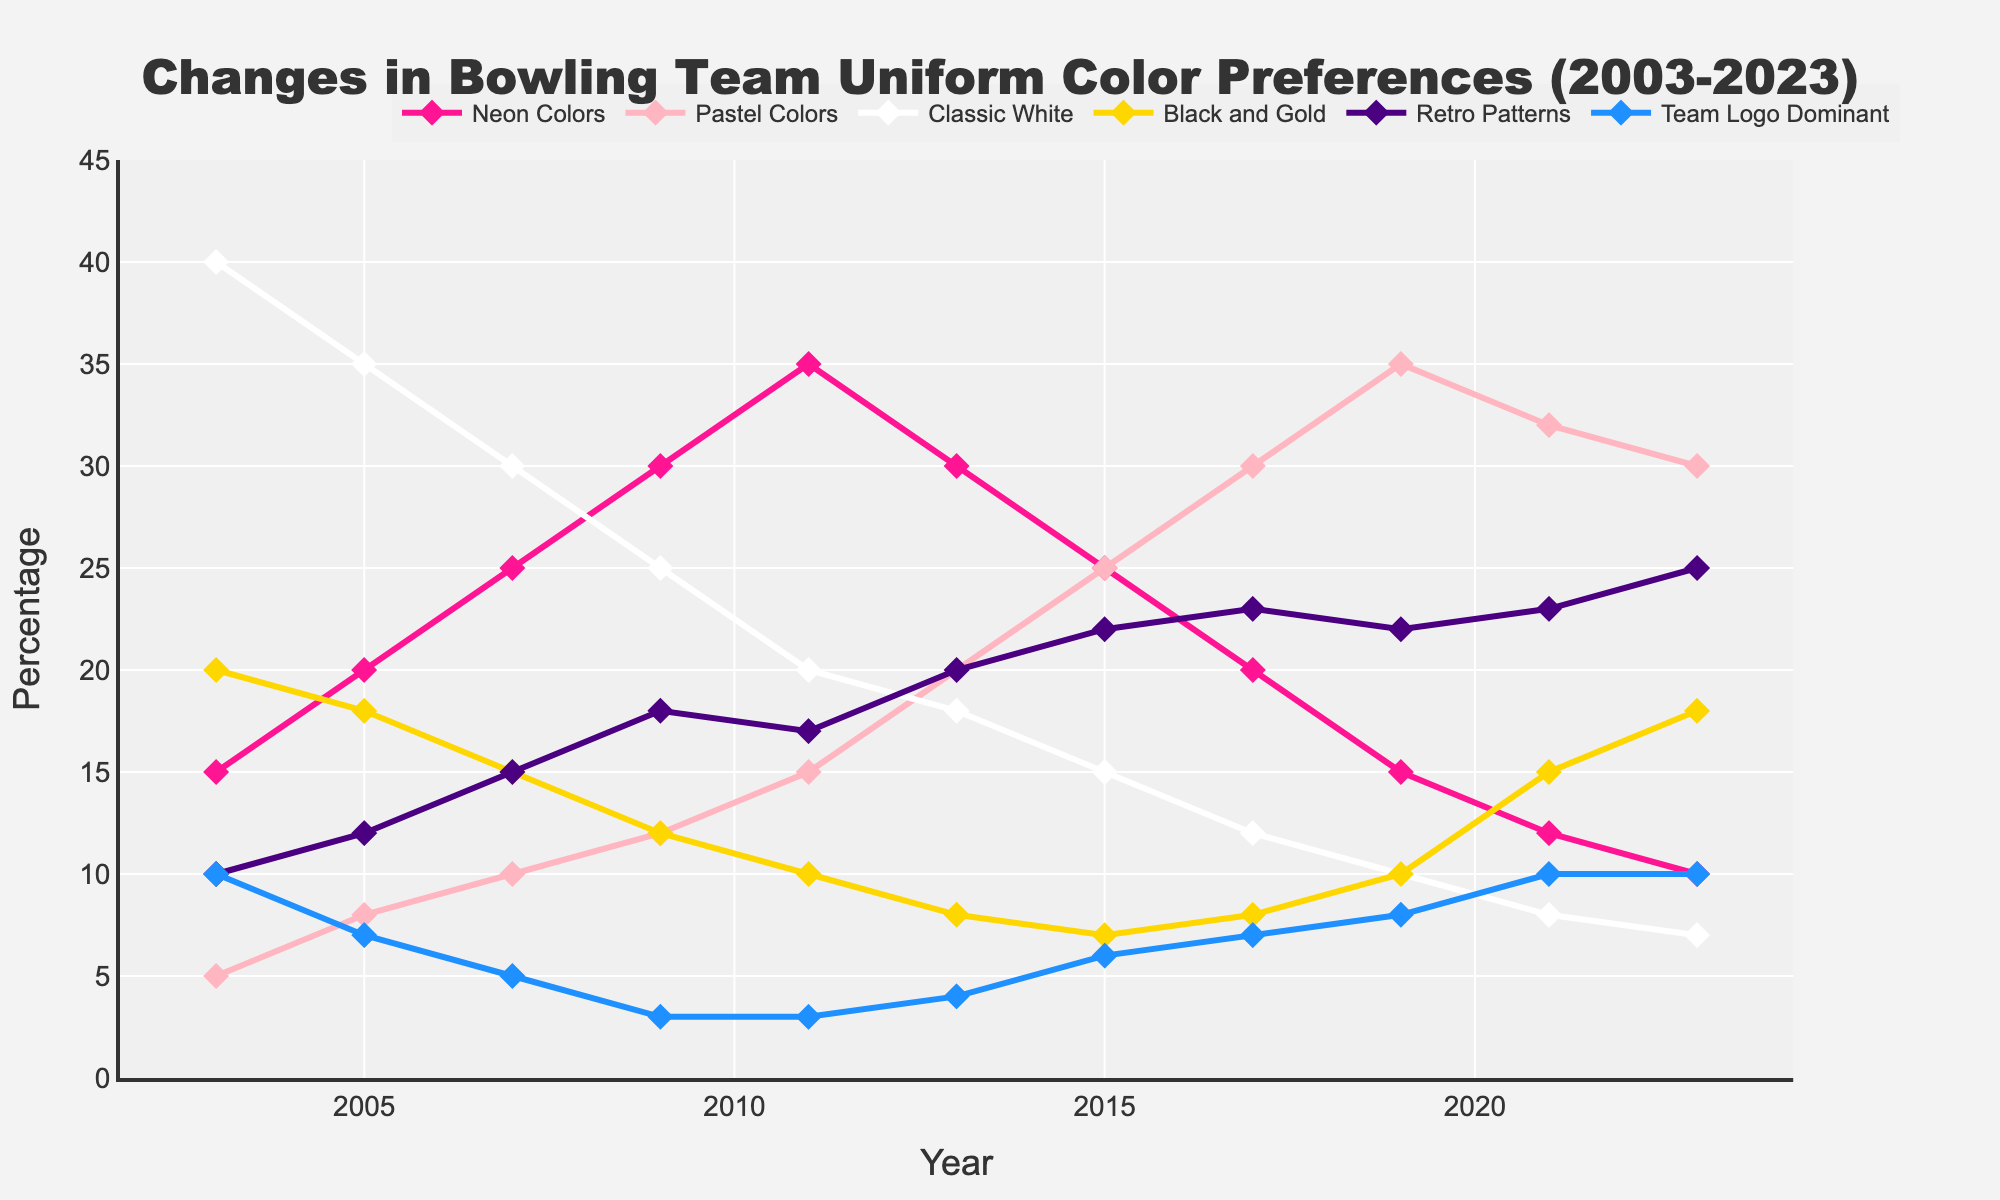What year had the highest preference for Neon Colors and what was the percentage? Looking at the trend of Neon Colors, the peak value is reached in 2011, where it is at its highest on the graph. The percentage at this point is 35%.
Answer: 2011, 35% Between which years did the preference for Pastel Colors increase the most? Analyzing the trend, the largest increase in Pastel Colors seems to occur between 2015 and 2017, where it jumps from 25% to 30%, an increase of 5%.
Answer: 2015 to 2017 In 2023, how does the preference for Black and Gold compare to Classic White? Observing the 2023 data points, Black and Gold has a value of 18% while Classic White is at 7%. Therefore, Black and Gold is more preferred than Classic White in 2023.
Answer: Black and Gold is more preferred What is the overall trend for Retro Patterns over the 20 years? Looking at Retro Patterns from 2003 to 2023, it starts at 10% and generally increases over time, ending at 25%. The trend is an increasing one.
Answer: Increasing Which color preference had the steepest decline between 2011 and 2023? Evaluating the lines, Neon Colors shows the steepest decline, dropping from 35% in 2011 to 10% in 2023, a decrease of 25%.
Answer: Neon Colors What are the average preferences for Team Logo Dominant over the recorded years? Summing up the percentages for Team Logo Dominant in each year and dividing by the number of years: (10+7+5+3+3+4+6+7+8+10+10) / 11 = 6.09% (rounded to 2 decimal places)
Answer: 6.09% In 2009, how does the preference for Classic White compare to Pastel Colors? In 2009, Classic White has a value of 25% while Pastel Colors is at 12%. Classic White is more preferred than Pastel Colors in 2009.
Answer: Classic White is more preferred What is the sum of preferences for Retro Patterns and Team Logo Dominant in 2023? Adding the percentages for Retro Patterns (25%) and Team Logo Dominant (10%) in 2023 gives a total of 35%.
Answer: 35% How did the preference for Classic White change from 2003 to 2023? Classic White starts at 40% in 2003 and decreases to 7% in 2023. This indicates a significant decline over the years.
Answer: Decreased significantly Which color preference had the smallest variation over the years? Observing the data trends, Team Logo Dominant shows the least variation, starting at 10% in 2003 and ending at 10% in 2023, with minor fluctuations in between.
Answer: Team Logo Dominant 